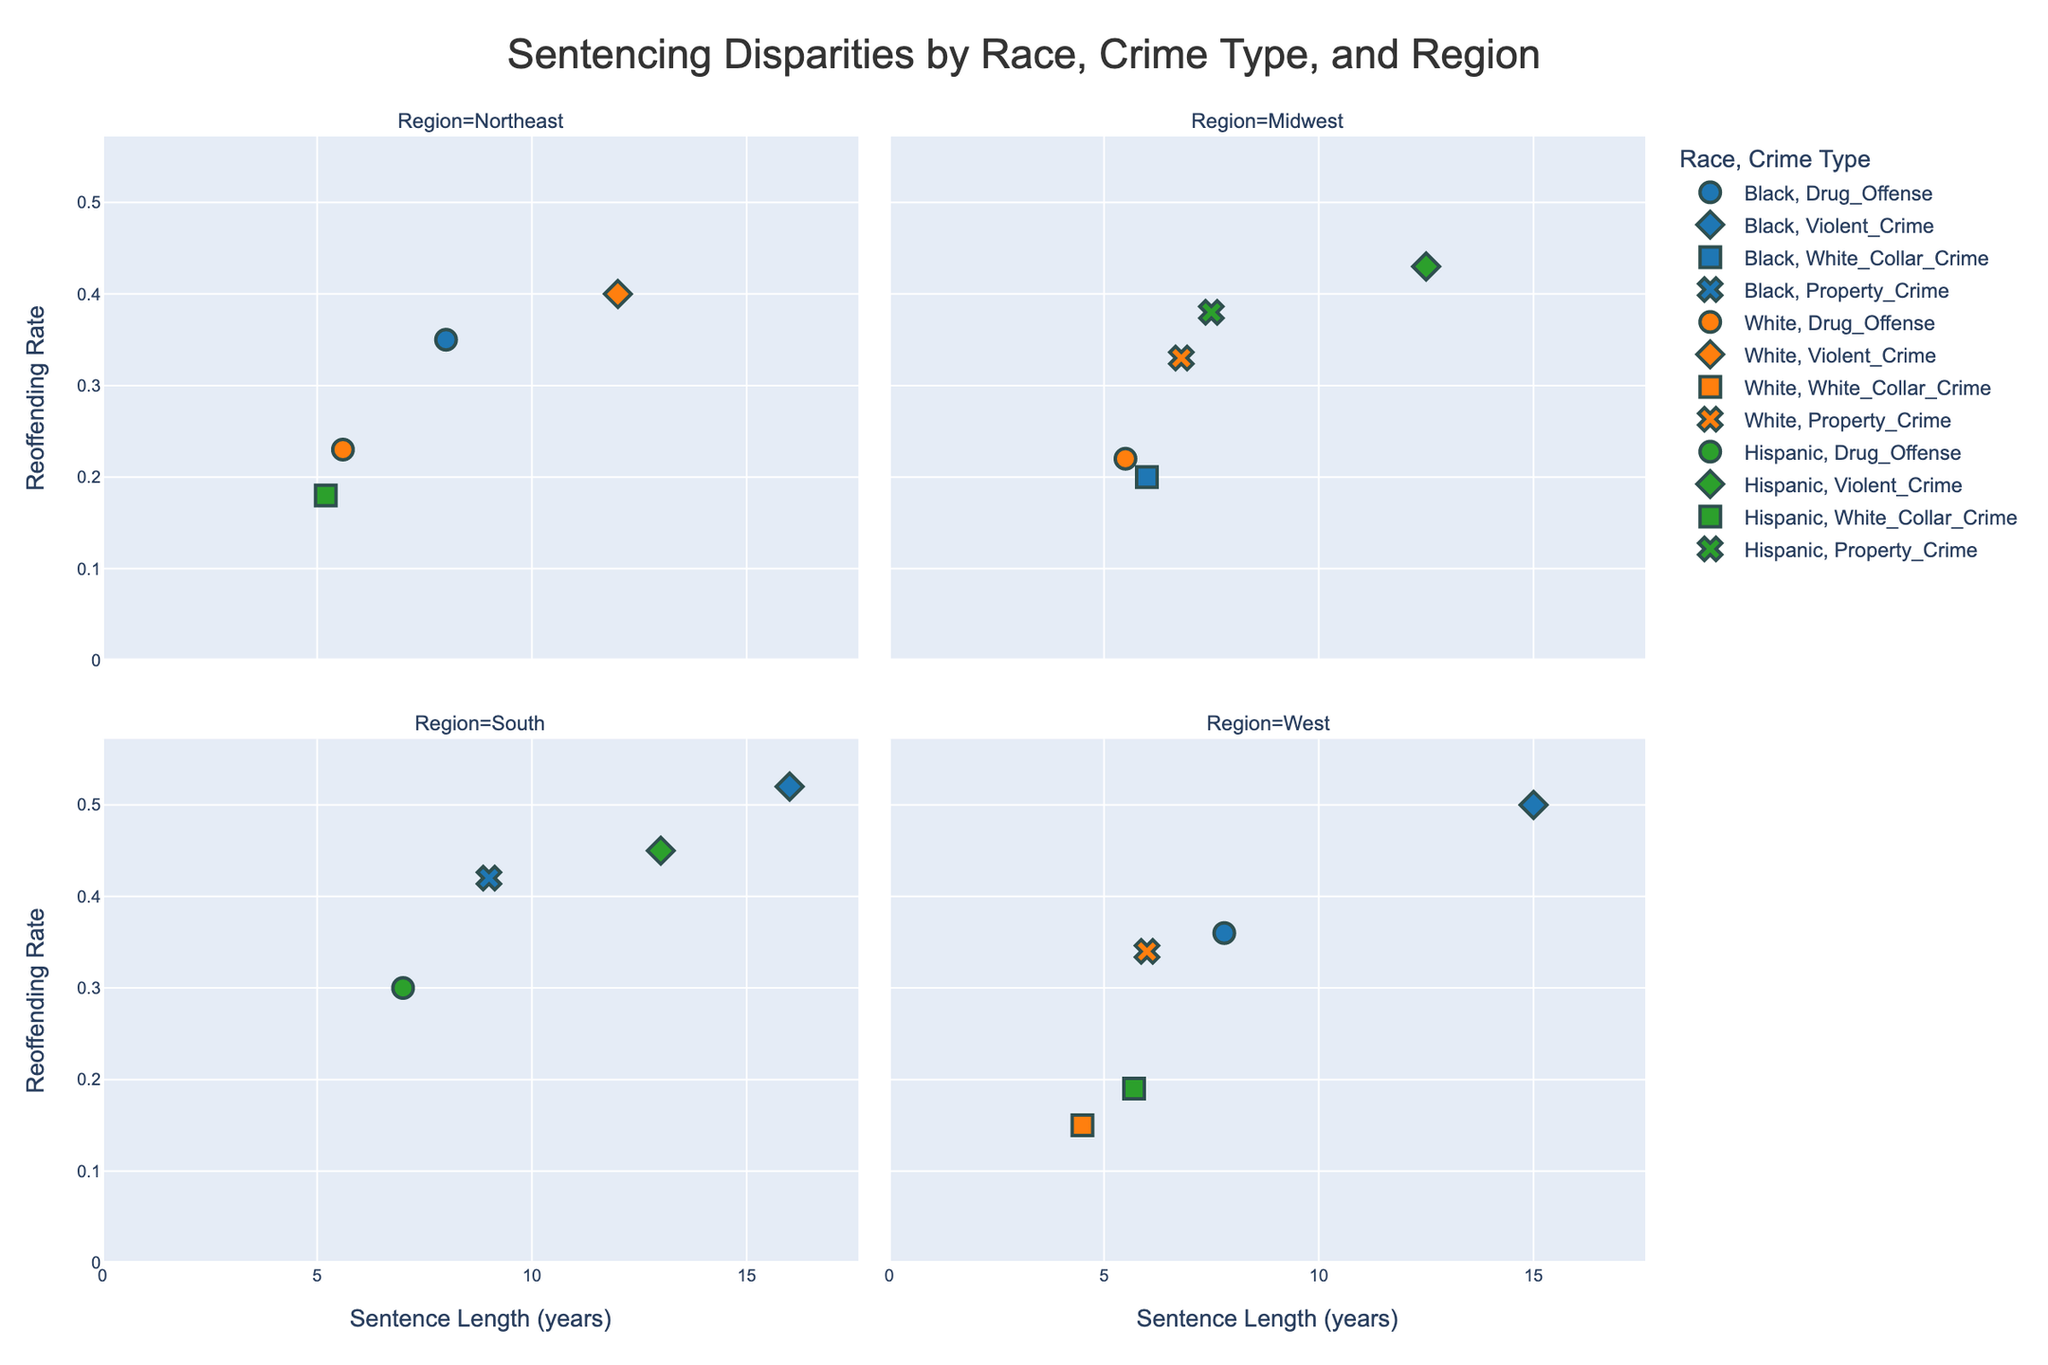What is the title of the plot? The title is typically displayed at the top of the plot and is often used to summarize the purpose of the visualization.
Answer: Sentencing Disparities by Race, Crime Type, and Region Which race has the highest reoffending rate for violent crimes in the South? To find this, locate the Violent Crime section for the South region and identify the race corresponding to the highest Reoffending Rate value.
Answer: Black What is the sentence length range for property crimes committed by Hispanics in the Midwest? Locate the Property Crime points for Hispanics in the Midwest region and identify the minimum and maximum Sentence Length values.
Answer: 7.5 years How do the reoffending rates for drug offenses compare between the West region and the Northeast? Identify the Drug Offense points in both the West and Northeast regions and compare their Reoffending Rate values.
Answer: Higher in the West What is the average reoffending rate for white-collar crimes committed by Whites in the Western region? Locate the White-Collar Crime points for Whites in the West, sum their Reoffending Rates, and divide by the number of points. (15%)
Answer: 15% Between Black and Hispanic offenders, who receives shorter sentences for property crimes in the South? Locate Property Crime points for both Black and Hispanic offenders in the South, then compare their Sentence Length values.
Answer: Hispanic How do sentence lengths for violent crimes in the Northeast compare between Black and White offenders? Identify the Violent Crime points in the Northeast for Black and White offenders and compare their Sentence Length values.
Answer: Longer for Black Which race has the lowest reoffending rate for white-collar crimes in the Midwest? Locate the White-Collar Crime section in the Midwest region and find the race with the lowest Reoffending Rate value.
Answer: Black What pattern can be observed for sentence lengths for drug offenses across different regions? Observe the Drug Offense points in various regions to identify if a particular region has consistently higher or lower Sentence Length values.
Answer: The South often has longer sentences Is there a correlation between sentence lengths and reoffending rates for violent crimes among Black offenders across all regions? Evaluate the points corresponding to violent crimes for Black offenders across all regions and look for a visible trend line or pattern.
Answer: Positive correlation (higher sentences often mean higher reoffending rates) 